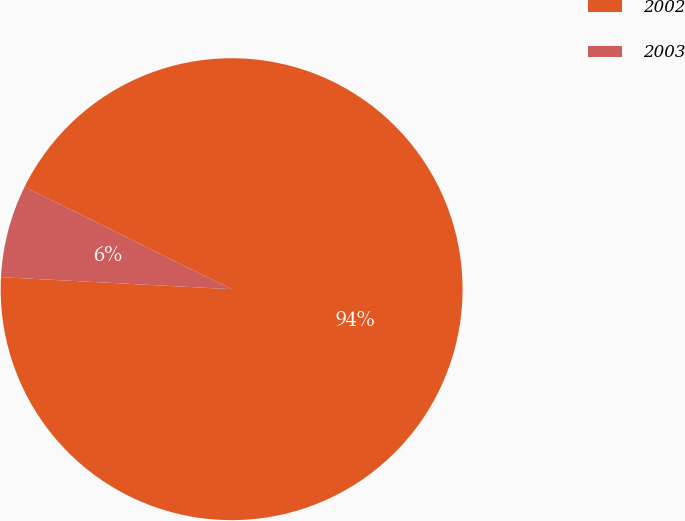Convert chart to OTSL. <chart><loc_0><loc_0><loc_500><loc_500><pie_chart><fcel>2002<fcel>2003<nl><fcel>93.52%<fcel>6.48%<nl></chart> 